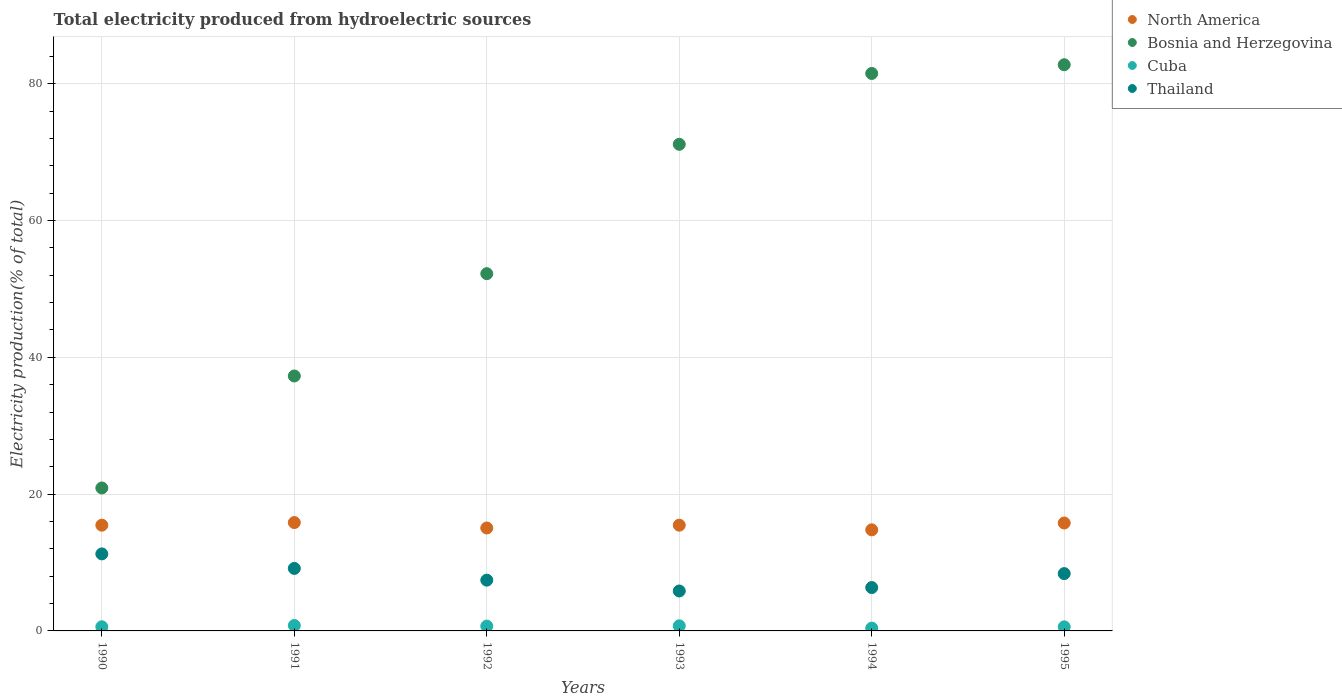How many different coloured dotlines are there?
Provide a succinct answer. 4. Is the number of dotlines equal to the number of legend labels?
Your answer should be compact. Yes. What is the total electricity produced in Bosnia and Herzegovina in 1995?
Your answer should be compact. 82.78. Across all years, what is the maximum total electricity produced in Cuba?
Your answer should be very brief. 0.79. Across all years, what is the minimum total electricity produced in Bosnia and Herzegovina?
Offer a very short reply. 20.9. What is the total total electricity produced in Bosnia and Herzegovina in the graph?
Your response must be concise. 345.83. What is the difference between the total electricity produced in North America in 1994 and that in 1995?
Offer a very short reply. -1. What is the difference between the total electricity produced in Cuba in 1993 and the total electricity produced in Thailand in 1991?
Give a very brief answer. -8.39. What is the average total electricity produced in North America per year?
Provide a short and direct response. 15.4. In the year 1991, what is the difference between the total electricity produced in North America and total electricity produced in Thailand?
Give a very brief answer. 6.7. What is the ratio of the total electricity produced in Cuba in 1993 to that in 1995?
Your response must be concise. 1.25. Is the total electricity produced in Thailand in 1990 less than that in 1993?
Offer a very short reply. No. What is the difference between the highest and the second highest total electricity produced in Cuba?
Give a very brief answer. 0.05. What is the difference between the highest and the lowest total electricity produced in Cuba?
Give a very brief answer. 0.38. Is the sum of the total electricity produced in Bosnia and Herzegovina in 1993 and 1995 greater than the maximum total electricity produced in North America across all years?
Your response must be concise. Yes. Is it the case that in every year, the sum of the total electricity produced in Cuba and total electricity produced in Bosnia and Herzegovina  is greater than the sum of total electricity produced in North America and total electricity produced in Thailand?
Offer a terse response. Yes. Is it the case that in every year, the sum of the total electricity produced in Cuba and total electricity produced in Bosnia and Herzegovina  is greater than the total electricity produced in North America?
Your answer should be compact. Yes. Does the total electricity produced in Thailand monotonically increase over the years?
Ensure brevity in your answer.  No. Is the total electricity produced in Bosnia and Herzegovina strictly less than the total electricity produced in North America over the years?
Keep it short and to the point. No. How many dotlines are there?
Offer a very short reply. 4. Are the values on the major ticks of Y-axis written in scientific E-notation?
Provide a short and direct response. No. Does the graph contain any zero values?
Ensure brevity in your answer.  No. Does the graph contain grids?
Give a very brief answer. Yes. Where does the legend appear in the graph?
Provide a succinct answer. Top right. How many legend labels are there?
Provide a short and direct response. 4. How are the legend labels stacked?
Provide a short and direct response. Vertical. What is the title of the graph?
Your answer should be compact. Total electricity produced from hydroelectric sources. What is the label or title of the X-axis?
Ensure brevity in your answer.  Years. What is the Electricity production(% of total) of North America in 1990?
Your answer should be compact. 15.46. What is the Electricity production(% of total) of Bosnia and Herzegovina in 1990?
Provide a short and direct response. 20.9. What is the Electricity production(% of total) of Cuba in 1990?
Your answer should be compact. 0.61. What is the Electricity production(% of total) of Thailand in 1990?
Your answer should be compact. 11.26. What is the Electricity production(% of total) of North America in 1991?
Your response must be concise. 15.84. What is the Electricity production(% of total) of Bosnia and Herzegovina in 1991?
Ensure brevity in your answer.  37.27. What is the Electricity production(% of total) in Cuba in 1991?
Provide a succinct answer. 0.79. What is the Electricity production(% of total) of Thailand in 1991?
Ensure brevity in your answer.  9.14. What is the Electricity production(% of total) in North America in 1992?
Provide a succinct answer. 15.05. What is the Electricity production(% of total) of Bosnia and Herzegovina in 1992?
Offer a terse response. 52.23. What is the Electricity production(% of total) in Cuba in 1992?
Your response must be concise. 0.7. What is the Electricity production(% of total) of Thailand in 1992?
Offer a very short reply. 7.42. What is the Electricity production(% of total) of North America in 1993?
Provide a short and direct response. 15.46. What is the Electricity production(% of total) in Bosnia and Herzegovina in 1993?
Keep it short and to the point. 71.15. What is the Electricity production(% of total) in Cuba in 1993?
Offer a very short reply. 0.75. What is the Electricity production(% of total) of Thailand in 1993?
Provide a short and direct response. 5.84. What is the Electricity production(% of total) in North America in 1994?
Your response must be concise. 14.78. What is the Electricity production(% of total) in Bosnia and Herzegovina in 1994?
Your answer should be compact. 81.5. What is the Electricity production(% of total) in Cuba in 1994?
Offer a very short reply. 0.41. What is the Electricity production(% of total) of Thailand in 1994?
Give a very brief answer. 6.34. What is the Electricity production(% of total) in North America in 1995?
Make the answer very short. 15.78. What is the Electricity production(% of total) of Bosnia and Herzegovina in 1995?
Your answer should be very brief. 82.78. What is the Electricity production(% of total) of Cuba in 1995?
Provide a succinct answer. 0.59. What is the Electricity production(% of total) of Thailand in 1995?
Offer a terse response. 8.38. Across all years, what is the maximum Electricity production(% of total) of North America?
Your answer should be very brief. 15.84. Across all years, what is the maximum Electricity production(% of total) in Bosnia and Herzegovina?
Ensure brevity in your answer.  82.78. Across all years, what is the maximum Electricity production(% of total) in Cuba?
Provide a succinct answer. 0.79. Across all years, what is the maximum Electricity production(% of total) of Thailand?
Give a very brief answer. 11.26. Across all years, what is the minimum Electricity production(% of total) in North America?
Your answer should be compact. 14.78. Across all years, what is the minimum Electricity production(% of total) of Bosnia and Herzegovina?
Provide a succinct answer. 20.9. Across all years, what is the minimum Electricity production(% of total) of Cuba?
Provide a short and direct response. 0.41. Across all years, what is the minimum Electricity production(% of total) in Thailand?
Give a very brief answer. 5.84. What is the total Electricity production(% of total) in North America in the graph?
Your response must be concise. 92.37. What is the total Electricity production(% of total) of Bosnia and Herzegovina in the graph?
Your answer should be very brief. 345.83. What is the total Electricity production(% of total) of Cuba in the graph?
Give a very brief answer. 3.85. What is the total Electricity production(% of total) in Thailand in the graph?
Provide a succinct answer. 48.38. What is the difference between the Electricity production(% of total) of North America in 1990 and that in 1991?
Keep it short and to the point. -0.38. What is the difference between the Electricity production(% of total) in Bosnia and Herzegovina in 1990 and that in 1991?
Your answer should be very brief. -16.37. What is the difference between the Electricity production(% of total) of Cuba in 1990 and that in 1991?
Give a very brief answer. -0.19. What is the difference between the Electricity production(% of total) in Thailand in 1990 and that in 1991?
Your answer should be very brief. 2.12. What is the difference between the Electricity production(% of total) of North America in 1990 and that in 1992?
Keep it short and to the point. 0.41. What is the difference between the Electricity production(% of total) in Bosnia and Herzegovina in 1990 and that in 1992?
Ensure brevity in your answer.  -31.33. What is the difference between the Electricity production(% of total) of Cuba in 1990 and that in 1992?
Your response must be concise. -0.1. What is the difference between the Electricity production(% of total) of Thailand in 1990 and that in 1992?
Keep it short and to the point. 3.84. What is the difference between the Electricity production(% of total) in North America in 1990 and that in 1993?
Offer a terse response. -0. What is the difference between the Electricity production(% of total) in Bosnia and Herzegovina in 1990 and that in 1993?
Give a very brief answer. -50.25. What is the difference between the Electricity production(% of total) in Cuba in 1990 and that in 1993?
Offer a terse response. -0.14. What is the difference between the Electricity production(% of total) in Thailand in 1990 and that in 1993?
Make the answer very short. 5.42. What is the difference between the Electricity production(% of total) of North America in 1990 and that in 1994?
Offer a terse response. 0.68. What is the difference between the Electricity production(% of total) in Bosnia and Herzegovina in 1990 and that in 1994?
Provide a short and direct response. -60.6. What is the difference between the Electricity production(% of total) in Cuba in 1990 and that in 1994?
Ensure brevity in your answer.  0.2. What is the difference between the Electricity production(% of total) in Thailand in 1990 and that in 1994?
Provide a succinct answer. 4.92. What is the difference between the Electricity production(% of total) in North America in 1990 and that in 1995?
Make the answer very short. -0.32. What is the difference between the Electricity production(% of total) of Bosnia and Herzegovina in 1990 and that in 1995?
Ensure brevity in your answer.  -61.88. What is the difference between the Electricity production(% of total) in Cuba in 1990 and that in 1995?
Your answer should be very brief. 0.01. What is the difference between the Electricity production(% of total) of Thailand in 1990 and that in 1995?
Keep it short and to the point. 2.88. What is the difference between the Electricity production(% of total) of North America in 1991 and that in 1992?
Offer a terse response. 0.79. What is the difference between the Electricity production(% of total) of Bosnia and Herzegovina in 1991 and that in 1992?
Give a very brief answer. -14.96. What is the difference between the Electricity production(% of total) of Cuba in 1991 and that in 1992?
Ensure brevity in your answer.  0.09. What is the difference between the Electricity production(% of total) in Thailand in 1991 and that in 1992?
Your answer should be compact. 1.72. What is the difference between the Electricity production(% of total) of North America in 1991 and that in 1993?
Make the answer very short. 0.38. What is the difference between the Electricity production(% of total) of Bosnia and Herzegovina in 1991 and that in 1993?
Offer a terse response. -33.87. What is the difference between the Electricity production(% of total) of Cuba in 1991 and that in 1993?
Provide a succinct answer. 0.05. What is the difference between the Electricity production(% of total) in Thailand in 1991 and that in 1993?
Your answer should be compact. 3.3. What is the difference between the Electricity production(% of total) of North America in 1991 and that in 1994?
Provide a short and direct response. 1.06. What is the difference between the Electricity production(% of total) of Bosnia and Herzegovina in 1991 and that in 1994?
Provide a short and direct response. -44.23. What is the difference between the Electricity production(% of total) in Cuba in 1991 and that in 1994?
Keep it short and to the point. 0.38. What is the difference between the Electricity production(% of total) of Thailand in 1991 and that in 1994?
Give a very brief answer. 2.8. What is the difference between the Electricity production(% of total) in North America in 1991 and that in 1995?
Ensure brevity in your answer.  0.07. What is the difference between the Electricity production(% of total) of Bosnia and Herzegovina in 1991 and that in 1995?
Your answer should be very brief. -45.5. What is the difference between the Electricity production(% of total) in Cuba in 1991 and that in 1995?
Keep it short and to the point. 0.2. What is the difference between the Electricity production(% of total) of Thailand in 1991 and that in 1995?
Make the answer very short. 0.76. What is the difference between the Electricity production(% of total) in North America in 1992 and that in 1993?
Provide a short and direct response. -0.41. What is the difference between the Electricity production(% of total) in Bosnia and Herzegovina in 1992 and that in 1993?
Make the answer very short. -18.92. What is the difference between the Electricity production(% of total) of Cuba in 1992 and that in 1993?
Offer a very short reply. -0.04. What is the difference between the Electricity production(% of total) in Thailand in 1992 and that in 1993?
Provide a short and direct response. 1.58. What is the difference between the Electricity production(% of total) of North America in 1992 and that in 1994?
Ensure brevity in your answer.  0.27. What is the difference between the Electricity production(% of total) of Bosnia and Herzegovina in 1992 and that in 1994?
Your response must be concise. -29.27. What is the difference between the Electricity production(% of total) of Cuba in 1992 and that in 1994?
Provide a short and direct response. 0.29. What is the difference between the Electricity production(% of total) of Thailand in 1992 and that in 1994?
Your answer should be compact. 1.08. What is the difference between the Electricity production(% of total) in North America in 1992 and that in 1995?
Ensure brevity in your answer.  -0.73. What is the difference between the Electricity production(% of total) of Bosnia and Herzegovina in 1992 and that in 1995?
Offer a very short reply. -30.55. What is the difference between the Electricity production(% of total) in Cuba in 1992 and that in 1995?
Your answer should be compact. 0.11. What is the difference between the Electricity production(% of total) in Thailand in 1992 and that in 1995?
Provide a succinct answer. -0.96. What is the difference between the Electricity production(% of total) in North America in 1993 and that in 1994?
Provide a succinct answer. 0.68. What is the difference between the Electricity production(% of total) of Bosnia and Herzegovina in 1993 and that in 1994?
Provide a succinct answer. -10.36. What is the difference between the Electricity production(% of total) in Cuba in 1993 and that in 1994?
Keep it short and to the point. 0.34. What is the difference between the Electricity production(% of total) in Thailand in 1993 and that in 1994?
Give a very brief answer. -0.5. What is the difference between the Electricity production(% of total) of North America in 1993 and that in 1995?
Your response must be concise. -0.32. What is the difference between the Electricity production(% of total) of Bosnia and Herzegovina in 1993 and that in 1995?
Keep it short and to the point. -11.63. What is the difference between the Electricity production(% of total) in Cuba in 1993 and that in 1995?
Provide a succinct answer. 0.15. What is the difference between the Electricity production(% of total) of Thailand in 1993 and that in 1995?
Keep it short and to the point. -2.54. What is the difference between the Electricity production(% of total) in North America in 1994 and that in 1995?
Provide a short and direct response. -1. What is the difference between the Electricity production(% of total) of Bosnia and Herzegovina in 1994 and that in 1995?
Offer a terse response. -1.27. What is the difference between the Electricity production(% of total) of Cuba in 1994 and that in 1995?
Offer a terse response. -0.18. What is the difference between the Electricity production(% of total) of Thailand in 1994 and that in 1995?
Your answer should be very brief. -2.04. What is the difference between the Electricity production(% of total) in North America in 1990 and the Electricity production(% of total) in Bosnia and Herzegovina in 1991?
Ensure brevity in your answer.  -21.81. What is the difference between the Electricity production(% of total) of North America in 1990 and the Electricity production(% of total) of Cuba in 1991?
Ensure brevity in your answer.  14.67. What is the difference between the Electricity production(% of total) in North America in 1990 and the Electricity production(% of total) in Thailand in 1991?
Provide a succinct answer. 6.32. What is the difference between the Electricity production(% of total) in Bosnia and Herzegovina in 1990 and the Electricity production(% of total) in Cuba in 1991?
Your answer should be very brief. 20.11. What is the difference between the Electricity production(% of total) in Bosnia and Herzegovina in 1990 and the Electricity production(% of total) in Thailand in 1991?
Give a very brief answer. 11.76. What is the difference between the Electricity production(% of total) in Cuba in 1990 and the Electricity production(% of total) in Thailand in 1991?
Your answer should be very brief. -8.53. What is the difference between the Electricity production(% of total) of North America in 1990 and the Electricity production(% of total) of Bosnia and Herzegovina in 1992?
Your answer should be very brief. -36.77. What is the difference between the Electricity production(% of total) of North America in 1990 and the Electricity production(% of total) of Cuba in 1992?
Provide a short and direct response. 14.76. What is the difference between the Electricity production(% of total) in North America in 1990 and the Electricity production(% of total) in Thailand in 1992?
Give a very brief answer. 8.04. What is the difference between the Electricity production(% of total) of Bosnia and Herzegovina in 1990 and the Electricity production(% of total) of Cuba in 1992?
Make the answer very short. 20.2. What is the difference between the Electricity production(% of total) in Bosnia and Herzegovina in 1990 and the Electricity production(% of total) in Thailand in 1992?
Your response must be concise. 13.48. What is the difference between the Electricity production(% of total) in Cuba in 1990 and the Electricity production(% of total) in Thailand in 1992?
Your answer should be compact. -6.82. What is the difference between the Electricity production(% of total) of North America in 1990 and the Electricity production(% of total) of Bosnia and Herzegovina in 1993?
Offer a very short reply. -55.69. What is the difference between the Electricity production(% of total) in North America in 1990 and the Electricity production(% of total) in Cuba in 1993?
Your answer should be very brief. 14.71. What is the difference between the Electricity production(% of total) in North America in 1990 and the Electricity production(% of total) in Thailand in 1993?
Provide a short and direct response. 9.62. What is the difference between the Electricity production(% of total) in Bosnia and Herzegovina in 1990 and the Electricity production(% of total) in Cuba in 1993?
Make the answer very short. 20.15. What is the difference between the Electricity production(% of total) in Bosnia and Herzegovina in 1990 and the Electricity production(% of total) in Thailand in 1993?
Give a very brief answer. 15.06. What is the difference between the Electricity production(% of total) of Cuba in 1990 and the Electricity production(% of total) of Thailand in 1993?
Your answer should be very brief. -5.23. What is the difference between the Electricity production(% of total) in North America in 1990 and the Electricity production(% of total) in Bosnia and Herzegovina in 1994?
Keep it short and to the point. -66.04. What is the difference between the Electricity production(% of total) in North America in 1990 and the Electricity production(% of total) in Cuba in 1994?
Make the answer very short. 15.05. What is the difference between the Electricity production(% of total) in North America in 1990 and the Electricity production(% of total) in Thailand in 1994?
Ensure brevity in your answer.  9.12. What is the difference between the Electricity production(% of total) of Bosnia and Herzegovina in 1990 and the Electricity production(% of total) of Cuba in 1994?
Give a very brief answer. 20.49. What is the difference between the Electricity production(% of total) of Bosnia and Herzegovina in 1990 and the Electricity production(% of total) of Thailand in 1994?
Give a very brief answer. 14.56. What is the difference between the Electricity production(% of total) of Cuba in 1990 and the Electricity production(% of total) of Thailand in 1994?
Your answer should be compact. -5.74. What is the difference between the Electricity production(% of total) of North America in 1990 and the Electricity production(% of total) of Bosnia and Herzegovina in 1995?
Your response must be concise. -67.32. What is the difference between the Electricity production(% of total) in North America in 1990 and the Electricity production(% of total) in Cuba in 1995?
Your response must be concise. 14.87. What is the difference between the Electricity production(% of total) of North America in 1990 and the Electricity production(% of total) of Thailand in 1995?
Offer a very short reply. 7.08. What is the difference between the Electricity production(% of total) of Bosnia and Herzegovina in 1990 and the Electricity production(% of total) of Cuba in 1995?
Offer a terse response. 20.31. What is the difference between the Electricity production(% of total) in Bosnia and Herzegovina in 1990 and the Electricity production(% of total) in Thailand in 1995?
Provide a succinct answer. 12.52. What is the difference between the Electricity production(% of total) in Cuba in 1990 and the Electricity production(% of total) in Thailand in 1995?
Keep it short and to the point. -7.78. What is the difference between the Electricity production(% of total) of North America in 1991 and the Electricity production(% of total) of Bosnia and Herzegovina in 1992?
Make the answer very short. -36.39. What is the difference between the Electricity production(% of total) in North America in 1991 and the Electricity production(% of total) in Cuba in 1992?
Offer a terse response. 15.14. What is the difference between the Electricity production(% of total) of North America in 1991 and the Electricity production(% of total) of Thailand in 1992?
Offer a terse response. 8.42. What is the difference between the Electricity production(% of total) of Bosnia and Herzegovina in 1991 and the Electricity production(% of total) of Cuba in 1992?
Offer a very short reply. 36.57. What is the difference between the Electricity production(% of total) of Bosnia and Herzegovina in 1991 and the Electricity production(% of total) of Thailand in 1992?
Your answer should be compact. 29.85. What is the difference between the Electricity production(% of total) in Cuba in 1991 and the Electricity production(% of total) in Thailand in 1992?
Make the answer very short. -6.63. What is the difference between the Electricity production(% of total) in North America in 1991 and the Electricity production(% of total) in Bosnia and Herzegovina in 1993?
Offer a very short reply. -55.3. What is the difference between the Electricity production(% of total) of North America in 1991 and the Electricity production(% of total) of Cuba in 1993?
Give a very brief answer. 15.1. What is the difference between the Electricity production(% of total) in North America in 1991 and the Electricity production(% of total) in Thailand in 1993?
Your answer should be compact. 10. What is the difference between the Electricity production(% of total) of Bosnia and Herzegovina in 1991 and the Electricity production(% of total) of Cuba in 1993?
Ensure brevity in your answer.  36.53. What is the difference between the Electricity production(% of total) of Bosnia and Herzegovina in 1991 and the Electricity production(% of total) of Thailand in 1993?
Ensure brevity in your answer.  31.43. What is the difference between the Electricity production(% of total) in Cuba in 1991 and the Electricity production(% of total) in Thailand in 1993?
Offer a terse response. -5.05. What is the difference between the Electricity production(% of total) in North America in 1991 and the Electricity production(% of total) in Bosnia and Herzegovina in 1994?
Offer a very short reply. -65.66. What is the difference between the Electricity production(% of total) in North America in 1991 and the Electricity production(% of total) in Cuba in 1994?
Keep it short and to the point. 15.43. What is the difference between the Electricity production(% of total) in North America in 1991 and the Electricity production(% of total) in Thailand in 1994?
Give a very brief answer. 9.5. What is the difference between the Electricity production(% of total) of Bosnia and Herzegovina in 1991 and the Electricity production(% of total) of Cuba in 1994?
Give a very brief answer. 36.86. What is the difference between the Electricity production(% of total) of Bosnia and Herzegovina in 1991 and the Electricity production(% of total) of Thailand in 1994?
Make the answer very short. 30.93. What is the difference between the Electricity production(% of total) in Cuba in 1991 and the Electricity production(% of total) in Thailand in 1994?
Offer a very short reply. -5.55. What is the difference between the Electricity production(% of total) of North America in 1991 and the Electricity production(% of total) of Bosnia and Herzegovina in 1995?
Your response must be concise. -66.93. What is the difference between the Electricity production(% of total) in North America in 1991 and the Electricity production(% of total) in Cuba in 1995?
Make the answer very short. 15.25. What is the difference between the Electricity production(% of total) of North America in 1991 and the Electricity production(% of total) of Thailand in 1995?
Give a very brief answer. 7.46. What is the difference between the Electricity production(% of total) of Bosnia and Herzegovina in 1991 and the Electricity production(% of total) of Cuba in 1995?
Make the answer very short. 36.68. What is the difference between the Electricity production(% of total) of Bosnia and Herzegovina in 1991 and the Electricity production(% of total) of Thailand in 1995?
Provide a short and direct response. 28.89. What is the difference between the Electricity production(% of total) in Cuba in 1991 and the Electricity production(% of total) in Thailand in 1995?
Your answer should be very brief. -7.59. What is the difference between the Electricity production(% of total) of North America in 1992 and the Electricity production(% of total) of Bosnia and Herzegovina in 1993?
Your answer should be very brief. -56.1. What is the difference between the Electricity production(% of total) of North America in 1992 and the Electricity production(% of total) of Cuba in 1993?
Offer a terse response. 14.3. What is the difference between the Electricity production(% of total) of North America in 1992 and the Electricity production(% of total) of Thailand in 1993?
Provide a short and direct response. 9.21. What is the difference between the Electricity production(% of total) of Bosnia and Herzegovina in 1992 and the Electricity production(% of total) of Cuba in 1993?
Your response must be concise. 51.48. What is the difference between the Electricity production(% of total) in Bosnia and Herzegovina in 1992 and the Electricity production(% of total) in Thailand in 1993?
Keep it short and to the point. 46.39. What is the difference between the Electricity production(% of total) of Cuba in 1992 and the Electricity production(% of total) of Thailand in 1993?
Offer a very short reply. -5.14. What is the difference between the Electricity production(% of total) in North America in 1992 and the Electricity production(% of total) in Bosnia and Herzegovina in 1994?
Your answer should be compact. -66.45. What is the difference between the Electricity production(% of total) of North America in 1992 and the Electricity production(% of total) of Cuba in 1994?
Keep it short and to the point. 14.64. What is the difference between the Electricity production(% of total) in North America in 1992 and the Electricity production(% of total) in Thailand in 1994?
Your response must be concise. 8.71. What is the difference between the Electricity production(% of total) in Bosnia and Herzegovina in 1992 and the Electricity production(% of total) in Cuba in 1994?
Your answer should be very brief. 51.82. What is the difference between the Electricity production(% of total) of Bosnia and Herzegovina in 1992 and the Electricity production(% of total) of Thailand in 1994?
Provide a succinct answer. 45.89. What is the difference between the Electricity production(% of total) of Cuba in 1992 and the Electricity production(% of total) of Thailand in 1994?
Your answer should be compact. -5.64. What is the difference between the Electricity production(% of total) in North America in 1992 and the Electricity production(% of total) in Bosnia and Herzegovina in 1995?
Provide a succinct answer. -67.73. What is the difference between the Electricity production(% of total) in North America in 1992 and the Electricity production(% of total) in Cuba in 1995?
Your answer should be compact. 14.46. What is the difference between the Electricity production(% of total) in North America in 1992 and the Electricity production(% of total) in Thailand in 1995?
Offer a terse response. 6.67. What is the difference between the Electricity production(% of total) in Bosnia and Herzegovina in 1992 and the Electricity production(% of total) in Cuba in 1995?
Your response must be concise. 51.64. What is the difference between the Electricity production(% of total) in Bosnia and Herzegovina in 1992 and the Electricity production(% of total) in Thailand in 1995?
Your answer should be compact. 43.85. What is the difference between the Electricity production(% of total) of Cuba in 1992 and the Electricity production(% of total) of Thailand in 1995?
Your answer should be very brief. -7.68. What is the difference between the Electricity production(% of total) in North America in 1993 and the Electricity production(% of total) in Bosnia and Herzegovina in 1994?
Keep it short and to the point. -66.04. What is the difference between the Electricity production(% of total) of North America in 1993 and the Electricity production(% of total) of Cuba in 1994?
Your answer should be compact. 15.05. What is the difference between the Electricity production(% of total) in North America in 1993 and the Electricity production(% of total) in Thailand in 1994?
Keep it short and to the point. 9.12. What is the difference between the Electricity production(% of total) in Bosnia and Herzegovina in 1993 and the Electricity production(% of total) in Cuba in 1994?
Give a very brief answer. 70.74. What is the difference between the Electricity production(% of total) of Bosnia and Herzegovina in 1993 and the Electricity production(% of total) of Thailand in 1994?
Give a very brief answer. 64.8. What is the difference between the Electricity production(% of total) in Cuba in 1993 and the Electricity production(% of total) in Thailand in 1994?
Offer a terse response. -5.6. What is the difference between the Electricity production(% of total) of North America in 1993 and the Electricity production(% of total) of Bosnia and Herzegovina in 1995?
Provide a short and direct response. -67.32. What is the difference between the Electricity production(% of total) in North America in 1993 and the Electricity production(% of total) in Cuba in 1995?
Offer a very short reply. 14.87. What is the difference between the Electricity production(% of total) in North America in 1993 and the Electricity production(% of total) in Thailand in 1995?
Offer a very short reply. 7.08. What is the difference between the Electricity production(% of total) of Bosnia and Herzegovina in 1993 and the Electricity production(% of total) of Cuba in 1995?
Give a very brief answer. 70.55. What is the difference between the Electricity production(% of total) in Bosnia and Herzegovina in 1993 and the Electricity production(% of total) in Thailand in 1995?
Ensure brevity in your answer.  62.76. What is the difference between the Electricity production(% of total) of Cuba in 1993 and the Electricity production(% of total) of Thailand in 1995?
Provide a short and direct response. -7.64. What is the difference between the Electricity production(% of total) of North America in 1994 and the Electricity production(% of total) of Bosnia and Herzegovina in 1995?
Your response must be concise. -68. What is the difference between the Electricity production(% of total) in North America in 1994 and the Electricity production(% of total) in Cuba in 1995?
Provide a succinct answer. 14.19. What is the difference between the Electricity production(% of total) of North America in 1994 and the Electricity production(% of total) of Thailand in 1995?
Your answer should be compact. 6.4. What is the difference between the Electricity production(% of total) of Bosnia and Herzegovina in 1994 and the Electricity production(% of total) of Cuba in 1995?
Provide a short and direct response. 80.91. What is the difference between the Electricity production(% of total) of Bosnia and Herzegovina in 1994 and the Electricity production(% of total) of Thailand in 1995?
Keep it short and to the point. 73.12. What is the difference between the Electricity production(% of total) in Cuba in 1994 and the Electricity production(% of total) in Thailand in 1995?
Keep it short and to the point. -7.97. What is the average Electricity production(% of total) of North America per year?
Your answer should be compact. 15.39. What is the average Electricity production(% of total) of Bosnia and Herzegovina per year?
Your answer should be compact. 57.64. What is the average Electricity production(% of total) of Cuba per year?
Provide a succinct answer. 0.64. What is the average Electricity production(% of total) in Thailand per year?
Make the answer very short. 8.06. In the year 1990, what is the difference between the Electricity production(% of total) of North America and Electricity production(% of total) of Bosnia and Herzegovina?
Give a very brief answer. -5.44. In the year 1990, what is the difference between the Electricity production(% of total) in North America and Electricity production(% of total) in Cuba?
Offer a very short reply. 14.85. In the year 1990, what is the difference between the Electricity production(% of total) in North America and Electricity production(% of total) in Thailand?
Your response must be concise. 4.2. In the year 1990, what is the difference between the Electricity production(% of total) in Bosnia and Herzegovina and Electricity production(% of total) in Cuba?
Provide a short and direct response. 20.29. In the year 1990, what is the difference between the Electricity production(% of total) in Bosnia and Herzegovina and Electricity production(% of total) in Thailand?
Ensure brevity in your answer.  9.64. In the year 1990, what is the difference between the Electricity production(% of total) of Cuba and Electricity production(% of total) of Thailand?
Offer a very short reply. -10.66. In the year 1991, what is the difference between the Electricity production(% of total) in North America and Electricity production(% of total) in Bosnia and Herzegovina?
Offer a very short reply. -21.43. In the year 1991, what is the difference between the Electricity production(% of total) of North America and Electricity production(% of total) of Cuba?
Your response must be concise. 15.05. In the year 1991, what is the difference between the Electricity production(% of total) in North America and Electricity production(% of total) in Thailand?
Provide a short and direct response. 6.7. In the year 1991, what is the difference between the Electricity production(% of total) of Bosnia and Herzegovina and Electricity production(% of total) of Cuba?
Offer a terse response. 36.48. In the year 1991, what is the difference between the Electricity production(% of total) of Bosnia and Herzegovina and Electricity production(% of total) of Thailand?
Give a very brief answer. 28.13. In the year 1991, what is the difference between the Electricity production(% of total) in Cuba and Electricity production(% of total) in Thailand?
Your response must be concise. -8.35. In the year 1992, what is the difference between the Electricity production(% of total) in North America and Electricity production(% of total) in Bosnia and Herzegovina?
Offer a terse response. -37.18. In the year 1992, what is the difference between the Electricity production(% of total) in North America and Electricity production(% of total) in Cuba?
Provide a short and direct response. 14.35. In the year 1992, what is the difference between the Electricity production(% of total) in North America and Electricity production(% of total) in Thailand?
Offer a very short reply. 7.63. In the year 1992, what is the difference between the Electricity production(% of total) in Bosnia and Herzegovina and Electricity production(% of total) in Cuba?
Provide a short and direct response. 51.53. In the year 1992, what is the difference between the Electricity production(% of total) in Bosnia and Herzegovina and Electricity production(% of total) in Thailand?
Keep it short and to the point. 44.81. In the year 1992, what is the difference between the Electricity production(% of total) in Cuba and Electricity production(% of total) in Thailand?
Provide a succinct answer. -6.72. In the year 1993, what is the difference between the Electricity production(% of total) in North America and Electricity production(% of total) in Bosnia and Herzegovina?
Provide a succinct answer. -55.69. In the year 1993, what is the difference between the Electricity production(% of total) of North America and Electricity production(% of total) of Cuba?
Provide a succinct answer. 14.71. In the year 1993, what is the difference between the Electricity production(% of total) of North America and Electricity production(% of total) of Thailand?
Provide a succinct answer. 9.62. In the year 1993, what is the difference between the Electricity production(% of total) of Bosnia and Herzegovina and Electricity production(% of total) of Cuba?
Give a very brief answer. 70.4. In the year 1993, what is the difference between the Electricity production(% of total) in Bosnia and Herzegovina and Electricity production(% of total) in Thailand?
Provide a succinct answer. 65.31. In the year 1993, what is the difference between the Electricity production(% of total) in Cuba and Electricity production(% of total) in Thailand?
Provide a short and direct response. -5.09. In the year 1994, what is the difference between the Electricity production(% of total) of North America and Electricity production(% of total) of Bosnia and Herzegovina?
Offer a terse response. -66.72. In the year 1994, what is the difference between the Electricity production(% of total) in North America and Electricity production(% of total) in Cuba?
Your response must be concise. 14.37. In the year 1994, what is the difference between the Electricity production(% of total) in North America and Electricity production(% of total) in Thailand?
Your answer should be compact. 8.44. In the year 1994, what is the difference between the Electricity production(% of total) in Bosnia and Herzegovina and Electricity production(% of total) in Cuba?
Your answer should be very brief. 81.09. In the year 1994, what is the difference between the Electricity production(% of total) of Bosnia and Herzegovina and Electricity production(% of total) of Thailand?
Give a very brief answer. 75.16. In the year 1994, what is the difference between the Electricity production(% of total) in Cuba and Electricity production(% of total) in Thailand?
Your answer should be very brief. -5.93. In the year 1995, what is the difference between the Electricity production(% of total) in North America and Electricity production(% of total) in Bosnia and Herzegovina?
Provide a short and direct response. -67. In the year 1995, what is the difference between the Electricity production(% of total) in North America and Electricity production(% of total) in Cuba?
Your answer should be very brief. 15.18. In the year 1995, what is the difference between the Electricity production(% of total) of North America and Electricity production(% of total) of Thailand?
Make the answer very short. 7.4. In the year 1995, what is the difference between the Electricity production(% of total) in Bosnia and Herzegovina and Electricity production(% of total) in Cuba?
Your answer should be compact. 82.18. In the year 1995, what is the difference between the Electricity production(% of total) of Bosnia and Herzegovina and Electricity production(% of total) of Thailand?
Offer a very short reply. 74.4. In the year 1995, what is the difference between the Electricity production(% of total) in Cuba and Electricity production(% of total) in Thailand?
Give a very brief answer. -7.79. What is the ratio of the Electricity production(% of total) in North America in 1990 to that in 1991?
Provide a succinct answer. 0.98. What is the ratio of the Electricity production(% of total) in Bosnia and Herzegovina in 1990 to that in 1991?
Your response must be concise. 0.56. What is the ratio of the Electricity production(% of total) of Cuba in 1990 to that in 1991?
Your answer should be compact. 0.76. What is the ratio of the Electricity production(% of total) in Thailand in 1990 to that in 1991?
Ensure brevity in your answer.  1.23. What is the ratio of the Electricity production(% of total) in North America in 1990 to that in 1992?
Your answer should be compact. 1.03. What is the ratio of the Electricity production(% of total) of Bosnia and Herzegovina in 1990 to that in 1992?
Provide a succinct answer. 0.4. What is the ratio of the Electricity production(% of total) in Cuba in 1990 to that in 1992?
Give a very brief answer. 0.86. What is the ratio of the Electricity production(% of total) of Thailand in 1990 to that in 1992?
Your answer should be compact. 1.52. What is the ratio of the Electricity production(% of total) in Bosnia and Herzegovina in 1990 to that in 1993?
Your answer should be compact. 0.29. What is the ratio of the Electricity production(% of total) in Cuba in 1990 to that in 1993?
Offer a very short reply. 0.81. What is the ratio of the Electricity production(% of total) of Thailand in 1990 to that in 1993?
Make the answer very short. 1.93. What is the ratio of the Electricity production(% of total) in North America in 1990 to that in 1994?
Give a very brief answer. 1.05. What is the ratio of the Electricity production(% of total) of Bosnia and Herzegovina in 1990 to that in 1994?
Provide a succinct answer. 0.26. What is the ratio of the Electricity production(% of total) in Cuba in 1990 to that in 1994?
Offer a terse response. 1.48. What is the ratio of the Electricity production(% of total) of Thailand in 1990 to that in 1994?
Your response must be concise. 1.78. What is the ratio of the Electricity production(% of total) of North America in 1990 to that in 1995?
Make the answer very short. 0.98. What is the ratio of the Electricity production(% of total) of Bosnia and Herzegovina in 1990 to that in 1995?
Keep it short and to the point. 0.25. What is the ratio of the Electricity production(% of total) of Cuba in 1990 to that in 1995?
Keep it short and to the point. 1.02. What is the ratio of the Electricity production(% of total) in Thailand in 1990 to that in 1995?
Ensure brevity in your answer.  1.34. What is the ratio of the Electricity production(% of total) of North America in 1991 to that in 1992?
Give a very brief answer. 1.05. What is the ratio of the Electricity production(% of total) in Bosnia and Herzegovina in 1991 to that in 1992?
Your answer should be compact. 0.71. What is the ratio of the Electricity production(% of total) of Cuba in 1991 to that in 1992?
Offer a terse response. 1.13. What is the ratio of the Electricity production(% of total) in Thailand in 1991 to that in 1992?
Offer a terse response. 1.23. What is the ratio of the Electricity production(% of total) of North America in 1991 to that in 1993?
Provide a succinct answer. 1.02. What is the ratio of the Electricity production(% of total) in Bosnia and Herzegovina in 1991 to that in 1993?
Your response must be concise. 0.52. What is the ratio of the Electricity production(% of total) in Cuba in 1991 to that in 1993?
Your response must be concise. 1.06. What is the ratio of the Electricity production(% of total) in Thailand in 1991 to that in 1993?
Provide a succinct answer. 1.57. What is the ratio of the Electricity production(% of total) of North America in 1991 to that in 1994?
Give a very brief answer. 1.07. What is the ratio of the Electricity production(% of total) of Bosnia and Herzegovina in 1991 to that in 1994?
Offer a terse response. 0.46. What is the ratio of the Electricity production(% of total) of Cuba in 1991 to that in 1994?
Offer a terse response. 1.94. What is the ratio of the Electricity production(% of total) of Thailand in 1991 to that in 1994?
Your answer should be very brief. 1.44. What is the ratio of the Electricity production(% of total) in North America in 1991 to that in 1995?
Give a very brief answer. 1. What is the ratio of the Electricity production(% of total) in Bosnia and Herzegovina in 1991 to that in 1995?
Your answer should be very brief. 0.45. What is the ratio of the Electricity production(% of total) in Cuba in 1991 to that in 1995?
Keep it short and to the point. 1.33. What is the ratio of the Electricity production(% of total) of Thailand in 1991 to that in 1995?
Your answer should be compact. 1.09. What is the ratio of the Electricity production(% of total) of North America in 1992 to that in 1993?
Your answer should be compact. 0.97. What is the ratio of the Electricity production(% of total) in Bosnia and Herzegovina in 1992 to that in 1993?
Give a very brief answer. 0.73. What is the ratio of the Electricity production(% of total) of Cuba in 1992 to that in 1993?
Provide a succinct answer. 0.94. What is the ratio of the Electricity production(% of total) of Thailand in 1992 to that in 1993?
Offer a terse response. 1.27. What is the ratio of the Electricity production(% of total) of North America in 1992 to that in 1994?
Give a very brief answer. 1.02. What is the ratio of the Electricity production(% of total) in Bosnia and Herzegovina in 1992 to that in 1994?
Provide a succinct answer. 0.64. What is the ratio of the Electricity production(% of total) in Cuba in 1992 to that in 1994?
Your answer should be very brief. 1.71. What is the ratio of the Electricity production(% of total) in Thailand in 1992 to that in 1994?
Provide a short and direct response. 1.17. What is the ratio of the Electricity production(% of total) in North America in 1992 to that in 1995?
Provide a succinct answer. 0.95. What is the ratio of the Electricity production(% of total) in Bosnia and Herzegovina in 1992 to that in 1995?
Offer a very short reply. 0.63. What is the ratio of the Electricity production(% of total) of Cuba in 1992 to that in 1995?
Make the answer very short. 1.18. What is the ratio of the Electricity production(% of total) in Thailand in 1992 to that in 1995?
Make the answer very short. 0.89. What is the ratio of the Electricity production(% of total) in North America in 1993 to that in 1994?
Your answer should be very brief. 1.05. What is the ratio of the Electricity production(% of total) in Bosnia and Herzegovina in 1993 to that in 1994?
Give a very brief answer. 0.87. What is the ratio of the Electricity production(% of total) of Cuba in 1993 to that in 1994?
Provide a short and direct response. 1.82. What is the ratio of the Electricity production(% of total) of Thailand in 1993 to that in 1994?
Keep it short and to the point. 0.92. What is the ratio of the Electricity production(% of total) in North America in 1993 to that in 1995?
Offer a very short reply. 0.98. What is the ratio of the Electricity production(% of total) in Bosnia and Herzegovina in 1993 to that in 1995?
Provide a succinct answer. 0.86. What is the ratio of the Electricity production(% of total) of Cuba in 1993 to that in 1995?
Provide a short and direct response. 1.25. What is the ratio of the Electricity production(% of total) in Thailand in 1993 to that in 1995?
Offer a terse response. 0.7. What is the ratio of the Electricity production(% of total) of North America in 1994 to that in 1995?
Offer a very short reply. 0.94. What is the ratio of the Electricity production(% of total) in Bosnia and Herzegovina in 1994 to that in 1995?
Provide a short and direct response. 0.98. What is the ratio of the Electricity production(% of total) in Cuba in 1994 to that in 1995?
Give a very brief answer. 0.69. What is the ratio of the Electricity production(% of total) of Thailand in 1994 to that in 1995?
Make the answer very short. 0.76. What is the difference between the highest and the second highest Electricity production(% of total) of North America?
Offer a terse response. 0.07. What is the difference between the highest and the second highest Electricity production(% of total) in Bosnia and Herzegovina?
Your answer should be compact. 1.27. What is the difference between the highest and the second highest Electricity production(% of total) of Cuba?
Make the answer very short. 0.05. What is the difference between the highest and the second highest Electricity production(% of total) in Thailand?
Keep it short and to the point. 2.12. What is the difference between the highest and the lowest Electricity production(% of total) in North America?
Your answer should be very brief. 1.06. What is the difference between the highest and the lowest Electricity production(% of total) of Bosnia and Herzegovina?
Ensure brevity in your answer.  61.88. What is the difference between the highest and the lowest Electricity production(% of total) in Cuba?
Offer a very short reply. 0.38. What is the difference between the highest and the lowest Electricity production(% of total) in Thailand?
Give a very brief answer. 5.42. 